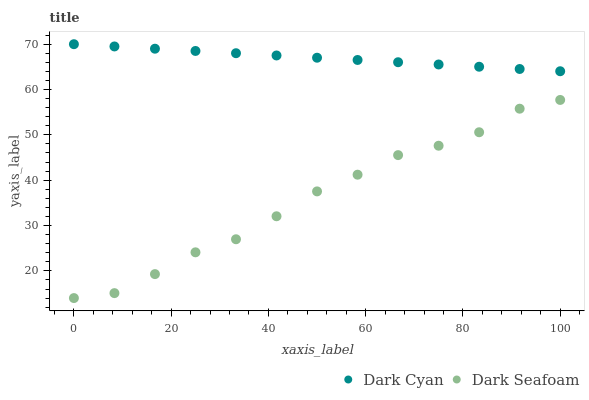Does Dark Seafoam have the minimum area under the curve?
Answer yes or no. Yes. Does Dark Cyan have the maximum area under the curve?
Answer yes or no. Yes. Does Dark Seafoam have the maximum area under the curve?
Answer yes or no. No. Is Dark Cyan the smoothest?
Answer yes or no. Yes. Is Dark Seafoam the roughest?
Answer yes or no. Yes. Is Dark Seafoam the smoothest?
Answer yes or no. No. Does Dark Seafoam have the lowest value?
Answer yes or no. Yes. Does Dark Cyan have the highest value?
Answer yes or no. Yes. Does Dark Seafoam have the highest value?
Answer yes or no. No. Is Dark Seafoam less than Dark Cyan?
Answer yes or no. Yes. Is Dark Cyan greater than Dark Seafoam?
Answer yes or no. Yes. Does Dark Seafoam intersect Dark Cyan?
Answer yes or no. No. 